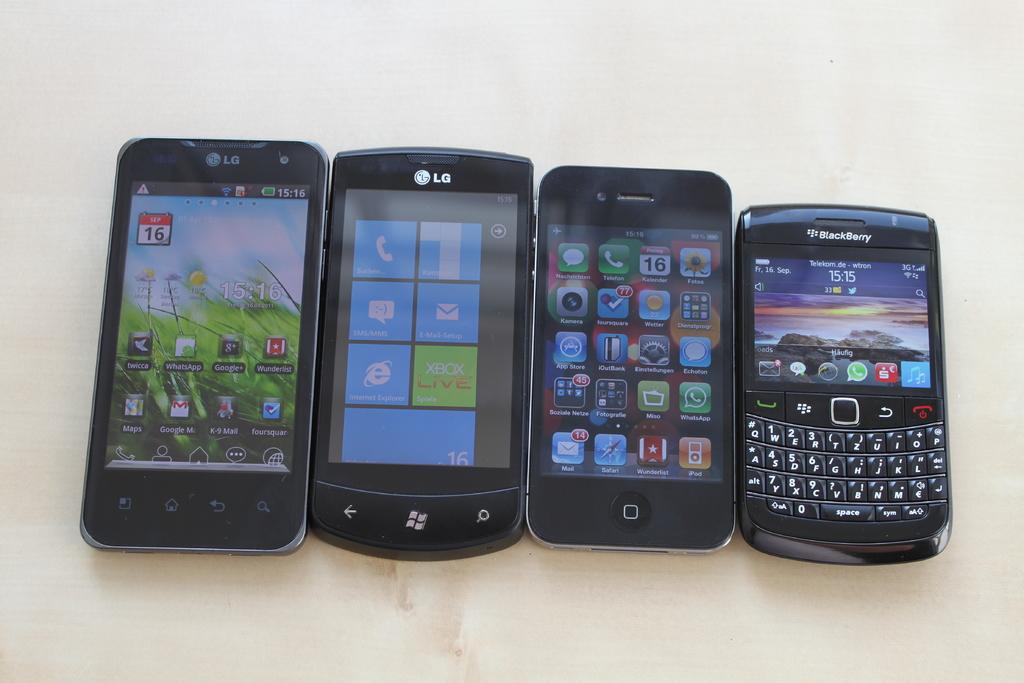What kind of phone is the phone on the far right?
Make the answer very short. Blackberry. What brand are the two phones on the left?
Make the answer very short. Lg. 